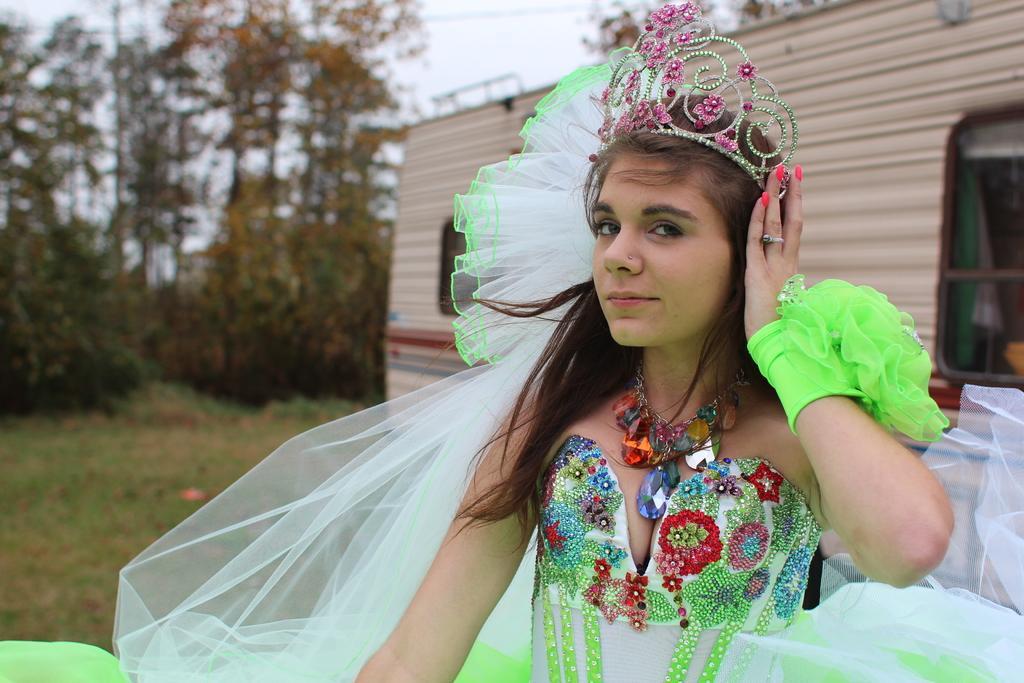How would you summarize this image in a sentence or two? In this picture there is a woman who is wearing a locket, white and green dress and crown. Behind her there is a van. In the background I can see many trees, plants and grass. At the top I can see the sky. 